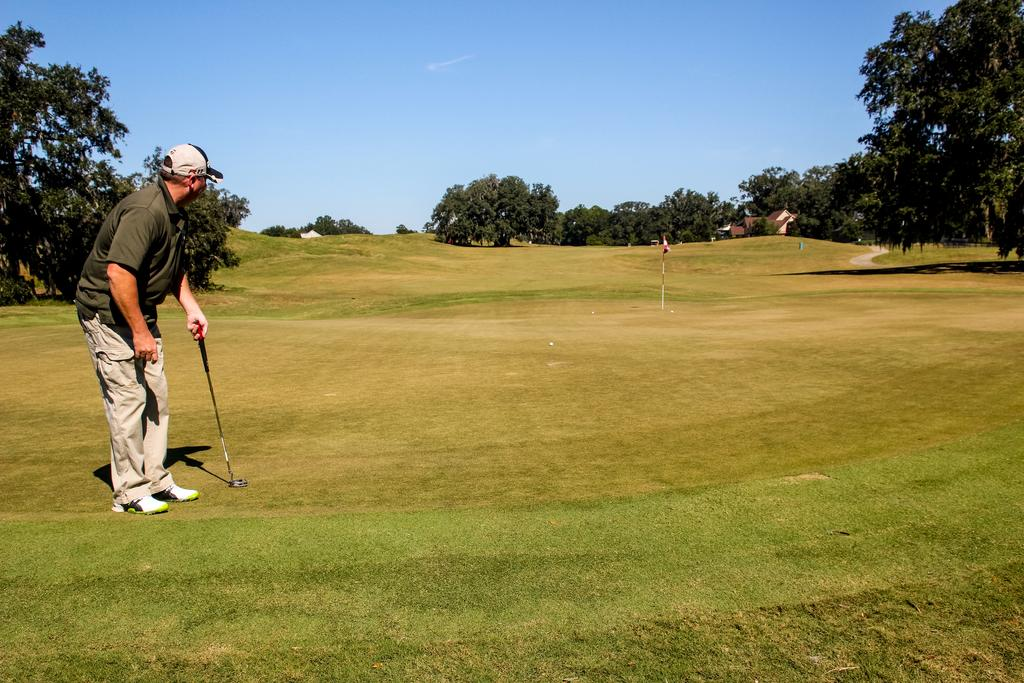Who is the main subject in the image? There is a man in the picture. What is the man doing in the image? The man is playing golf. Where is the golf being played? The golf is being played on a ground. What can be seen in the background of the golf ground? There are trees around the golf ground. What type of fear can be seen on the ducks' faces in the image? There are no ducks present in the image, so it is not possible to determine if they are experiencing any fear. 